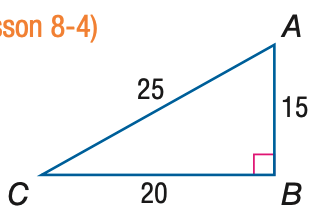Answer the mathemtical geometry problem and directly provide the correct option letter.
Question: Express the ratio of \tan A as a decimal to the nearest hundredth.
Choices: A: 0.60 B: 0.80 C: 1.33 D: 1.67 C 